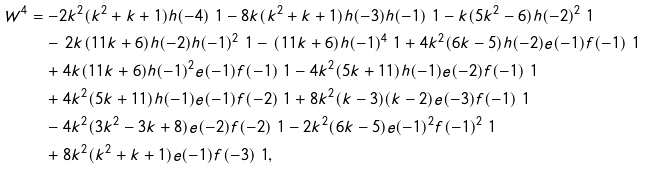<formula> <loc_0><loc_0><loc_500><loc_500>W ^ { 4 } & = - 2 k ^ { 2 } ( k ^ { 2 } + k + 1 ) h ( - 4 ) \ 1 - 8 k ( k ^ { 2 } + k + 1 ) h ( - 3 ) h ( - 1 ) \ 1 - k ( 5 k ^ { 2 } - 6 ) h ( - 2 ) ^ { 2 } \ 1 \\ & \quad - \, 2 k ( 1 1 k + 6 ) h ( - 2 ) h ( - 1 ) ^ { 2 } \ 1 - \, ( 1 1 k + 6 ) h ( - 1 ) ^ { 4 } \ 1 + 4 k ^ { 2 } ( 6 k - 5 ) h ( - 2 ) e ( - 1 ) f ( - 1 ) \ 1 \\ & \quad + 4 k ( 1 1 k + 6 ) h ( - 1 ) ^ { 2 } e ( - 1 ) f ( - 1 ) \ 1 - 4 k ^ { 2 } ( 5 k + 1 1 ) h ( - 1 ) e ( - 2 ) f ( - 1 ) \ 1 \\ & \quad + 4 k ^ { 2 } ( 5 k + 1 1 ) h ( - 1 ) e ( - 1 ) f ( - 2 ) \ 1 + 8 k ^ { 2 } ( k - 3 ) ( k - 2 ) e ( - 3 ) f ( - 1 ) \ 1 \\ & \quad - 4 k ^ { 2 } ( 3 k ^ { 2 } - 3 k + 8 ) e ( - 2 ) f ( - 2 ) \ 1 - 2 k ^ { 2 } ( 6 k - 5 ) e ( - 1 ) ^ { 2 } f ( - 1 ) ^ { 2 } \ 1 \\ & \quad + 8 k ^ { 2 } ( k ^ { 2 } + k + 1 ) e ( - 1 ) f ( - 3 ) \ 1 ,</formula> 